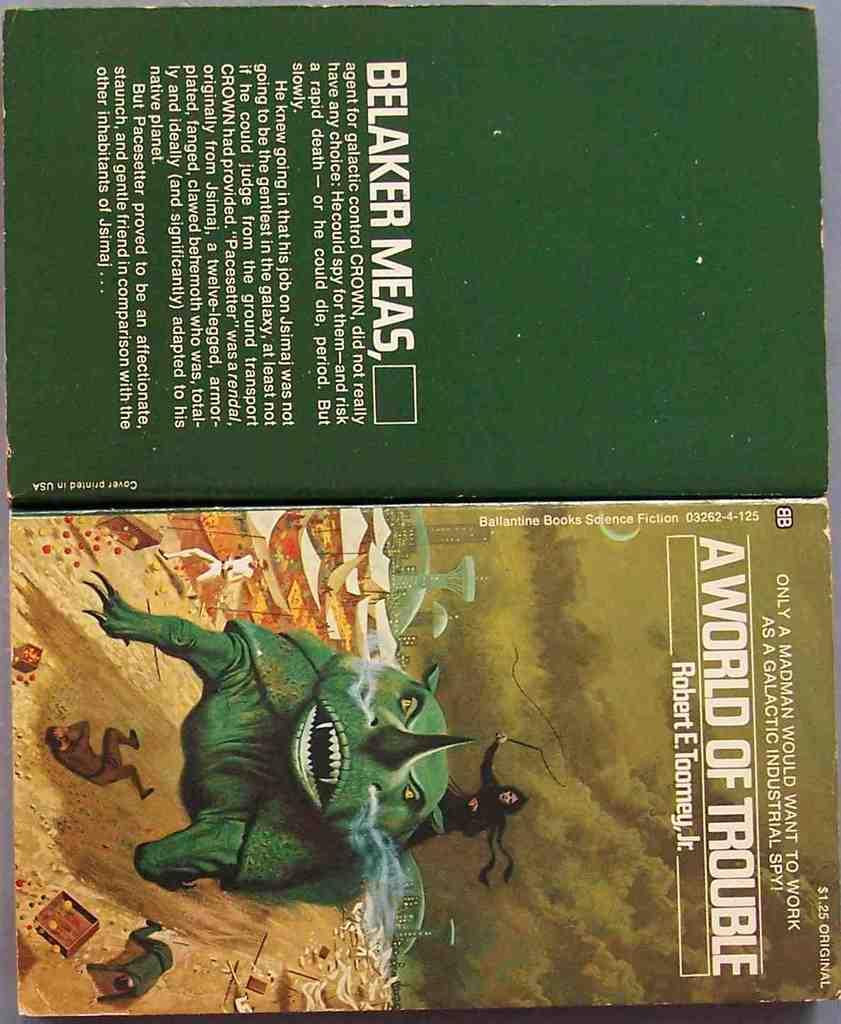<image>
Provide a brief description of the given image. A book cover for a book called A World of Trouble showing a man riding a green rhino. 